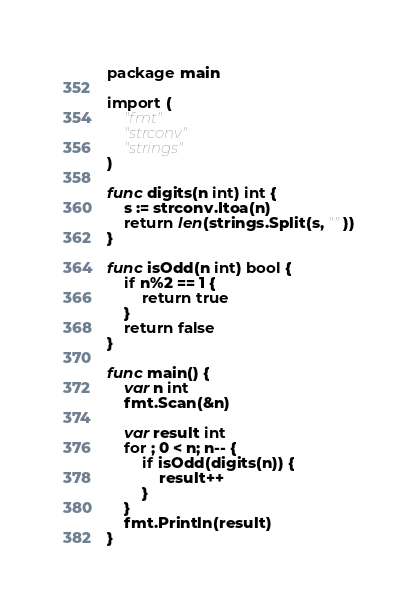Convert code to text. <code><loc_0><loc_0><loc_500><loc_500><_Go_>package main

import (
	"fmt"
	"strconv"
	"strings"
)

func digits(n int) int {
	s := strconv.Itoa(n)
	return len(strings.Split(s, ""))
}

func isOdd(n int) bool {
	if n%2 == 1 {
		return true
	}
	return false
}

func main() {
	var n int
	fmt.Scan(&n)

	var result int
	for ; 0 < n; n-- {
		if isOdd(digits(n)) {
			result++
		}
	}
	fmt.Println(result)
}
</code> 